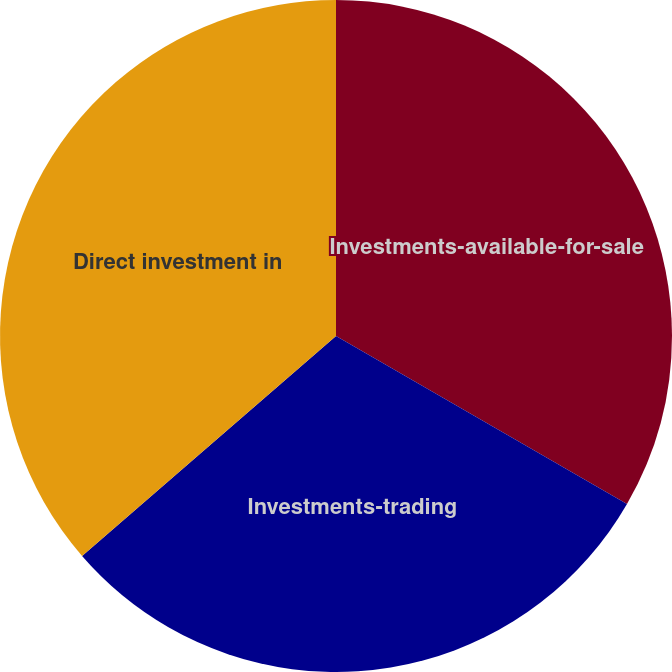Convert chart to OTSL. <chart><loc_0><loc_0><loc_500><loc_500><pie_chart><fcel>Investments-available-for-sale<fcel>Investments-trading<fcel>Direct investment in<nl><fcel>33.33%<fcel>30.3%<fcel>36.36%<nl></chart> 